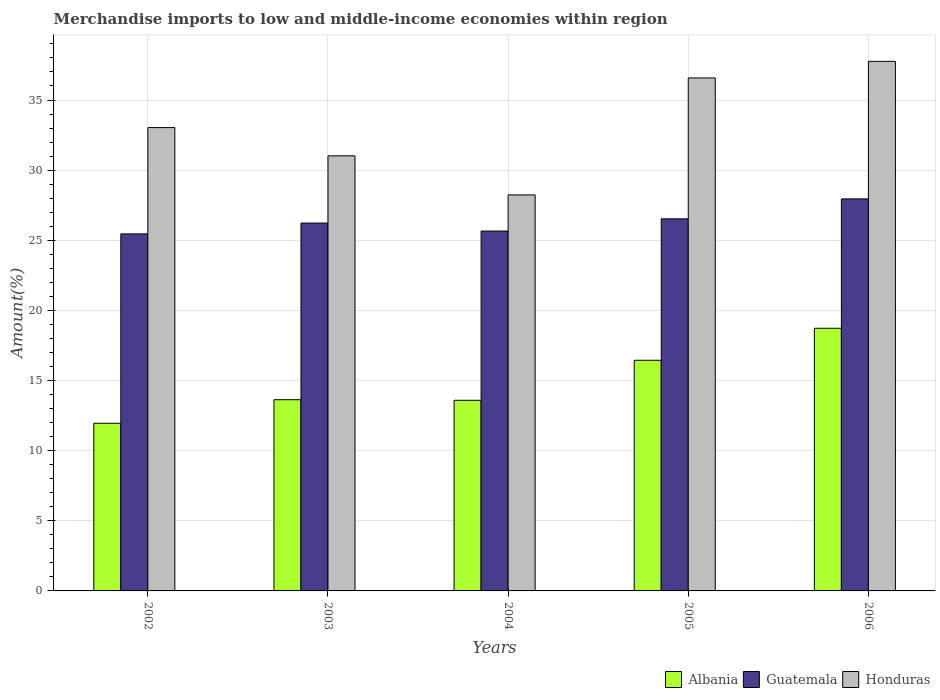Are the number of bars on each tick of the X-axis equal?
Your answer should be very brief. Yes. What is the label of the 1st group of bars from the left?
Offer a very short reply. 2002. In how many cases, is the number of bars for a given year not equal to the number of legend labels?
Make the answer very short. 0. What is the percentage of amount earned from merchandise imports in Albania in 2003?
Your answer should be compact. 13.63. Across all years, what is the maximum percentage of amount earned from merchandise imports in Albania?
Your answer should be very brief. 18.73. Across all years, what is the minimum percentage of amount earned from merchandise imports in Honduras?
Ensure brevity in your answer.  28.23. In which year was the percentage of amount earned from merchandise imports in Albania minimum?
Your answer should be compact. 2002. What is the total percentage of amount earned from merchandise imports in Guatemala in the graph?
Your answer should be very brief. 131.81. What is the difference between the percentage of amount earned from merchandise imports in Albania in 2003 and that in 2006?
Ensure brevity in your answer.  -5.09. What is the difference between the percentage of amount earned from merchandise imports in Albania in 2005 and the percentage of amount earned from merchandise imports in Guatemala in 2002?
Offer a very short reply. -9.01. What is the average percentage of amount earned from merchandise imports in Honduras per year?
Give a very brief answer. 33.32. In the year 2006, what is the difference between the percentage of amount earned from merchandise imports in Guatemala and percentage of amount earned from merchandise imports in Albania?
Provide a succinct answer. 9.22. What is the ratio of the percentage of amount earned from merchandise imports in Albania in 2002 to that in 2006?
Your answer should be compact. 0.64. What is the difference between the highest and the second highest percentage of amount earned from merchandise imports in Guatemala?
Keep it short and to the point. 1.42. What is the difference between the highest and the lowest percentage of amount earned from merchandise imports in Albania?
Ensure brevity in your answer.  6.77. In how many years, is the percentage of amount earned from merchandise imports in Albania greater than the average percentage of amount earned from merchandise imports in Albania taken over all years?
Your answer should be compact. 2. What does the 3rd bar from the left in 2005 represents?
Provide a succinct answer. Honduras. What does the 3rd bar from the right in 2006 represents?
Offer a very short reply. Albania. How many years are there in the graph?
Provide a succinct answer. 5. What is the difference between two consecutive major ticks on the Y-axis?
Make the answer very short. 5. Does the graph contain grids?
Your answer should be very brief. Yes. Where does the legend appear in the graph?
Make the answer very short. Bottom right. How many legend labels are there?
Your answer should be compact. 3. How are the legend labels stacked?
Provide a short and direct response. Horizontal. What is the title of the graph?
Your answer should be very brief. Merchandise imports to low and middle-income economies within region. What is the label or title of the X-axis?
Your response must be concise. Years. What is the label or title of the Y-axis?
Provide a short and direct response. Amount(%). What is the Amount(%) of Albania in 2002?
Ensure brevity in your answer.  11.95. What is the Amount(%) of Guatemala in 2002?
Your answer should be very brief. 25.45. What is the Amount(%) of Honduras in 2002?
Offer a terse response. 33.03. What is the Amount(%) in Albania in 2003?
Provide a short and direct response. 13.63. What is the Amount(%) in Guatemala in 2003?
Your answer should be compact. 26.23. What is the Amount(%) in Honduras in 2003?
Your answer should be very brief. 31.02. What is the Amount(%) of Albania in 2004?
Provide a succinct answer. 13.59. What is the Amount(%) in Guatemala in 2004?
Offer a terse response. 25.66. What is the Amount(%) in Honduras in 2004?
Provide a short and direct response. 28.23. What is the Amount(%) in Albania in 2005?
Make the answer very short. 16.44. What is the Amount(%) in Guatemala in 2005?
Provide a succinct answer. 26.53. What is the Amount(%) of Honduras in 2005?
Ensure brevity in your answer.  36.57. What is the Amount(%) in Albania in 2006?
Offer a terse response. 18.73. What is the Amount(%) of Guatemala in 2006?
Provide a succinct answer. 27.95. What is the Amount(%) of Honduras in 2006?
Make the answer very short. 37.76. Across all years, what is the maximum Amount(%) of Albania?
Offer a terse response. 18.73. Across all years, what is the maximum Amount(%) of Guatemala?
Give a very brief answer. 27.95. Across all years, what is the maximum Amount(%) in Honduras?
Offer a terse response. 37.76. Across all years, what is the minimum Amount(%) in Albania?
Offer a terse response. 11.95. Across all years, what is the minimum Amount(%) of Guatemala?
Provide a short and direct response. 25.45. Across all years, what is the minimum Amount(%) of Honduras?
Provide a short and direct response. 28.23. What is the total Amount(%) in Albania in the graph?
Your answer should be very brief. 74.35. What is the total Amount(%) of Guatemala in the graph?
Give a very brief answer. 131.81. What is the total Amount(%) of Honduras in the graph?
Offer a very short reply. 166.62. What is the difference between the Amount(%) in Albania in 2002 and that in 2003?
Provide a short and direct response. -1.68. What is the difference between the Amount(%) of Guatemala in 2002 and that in 2003?
Provide a short and direct response. -0.77. What is the difference between the Amount(%) of Honduras in 2002 and that in 2003?
Make the answer very short. 2.01. What is the difference between the Amount(%) in Albania in 2002 and that in 2004?
Provide a short and direct response. -1.64. What is the difference between the Amount(%) in Guatemala in 2002 and that in 2004?
Make the answer very short. -0.2. What is the difference between the Amount(%) of Honduras in 2002 and that in 2004?
Provide a short and direct response. 4.8. What is the difference between the Amount(%) of Albania in 2002 and that in 2005?
Provide a short and direct response. -4.49. What is the difference between the Amount(%) of Guatemala in 2002 and that in 2005?
Your answer should be very brief. -1.07. What is the difference between the Amount(%) in Honduras in 2002 and that in 2005?
Give a very brief answer. -3.54. What is the difference between the Amount(%) of Albania in 2002 and that in 2006?
Ensure brevity in your answer.  -6.77. What is the difference between the Amount(%) in Guatemala in 2002 and that in 2006?
Give a very brief answer. -2.49. What is the difference between the Amount(%) in Honduras in 2002 and that in 2006?
Offer a very short reply. -4.72. What is the difference between the Amount(%) of Albania in 2003 and that in 2004?
Make the answer very short. 0.04. What is the difference between the Amount(%) of Guatemala in 2003 and that in 2004?
Keep it short and to the point. 0.57. What is the difference between the Amount(%) in Honduras in 2003 and that in 2004?
Provide a short and direct response. 2.79. What is the difference between the Amount(%) in Albania in 2003 and that in 2005?
Offer a very short reply. -2.81. What is the difference between the Amount(%) in Guatemala in 2003 and that in 2005?
Provide a short and direct response. -0.3. What is the difference between the Amount(%) in Honduras in 2003 and that in 2005?
Provide a short and direct response. -5.55. What is the difference between the Amount(%) in Albania in 2003 and that in 2006?
Offer a terse response. -5.09. What is the difference between the Amount(%) in Guatemala in 2003 and that in 2006?
Your response must be concise. -1.72. What is the difference between the Amount(%) in Honduras in 2003 and that in 2006?
Your response must be concise. -6.74. What is the difference between the Amount(%) in Albania in 2004 and that in 2005?
Offer a terse response. -2.85. What is the difference between the Amount(%) of Guatemala in 2004 and that in 2005?
Provide a short and direct response. -0.87. What is the difference between the Amount(%) in Honduras in 2004 and that in 2005?
Offer a terse response. -8.34. What is the difference between the Amount(%) of Albania in 2004 and that in 2006?
Make the answer very short. -5.14. What is the difference between the Amount(%) of Guatemala in 2004 and that in 2006?
Offer a terse response. -2.29. What is the difference between the Amount(%) in Honduras in 2004 and that in 2006?
Ensure brevity in your answer.  -9.52. What is the difference between the Amount(%) in Albania in 2005 and that in 2006?
Make the answer very short. -2.28. What is the difference between the Amount(%) in Guatemala in 2005 and that in 2006?
Make the answer very short. -1.42. What is the difference between the Amount(%) in Honduras in 2005 and that in 2006?
Your answer should be very brief. -1.18. What is the difference between the Amount(%) in Albania in 2002 and the Amount(%) in Guatemala in 2003?
Your response must be concise. -14.27. What is the difference between the Amount(%) in Albania in 2002 and the Amount(%) in Honduras in 2003?
Offer a terse response. -19.07. What is the difference between the Amount(%) of Guatemala in 2002 and the Amount(%) of Honduras in 2003?
Provide a short and direct response. -5.56. What is the difference between the Amount(%) of Albania in 2002 and the Amount(%) of Guatemala in 2004?
Ensure brevity in your answer.  -13.7. What is the difference between the Amount(%) in Albania in 2002 and the Amount(%) in Honduras in 2004?
Provide a succinct answer. -16.28. What is the difference between the Amount(%) in Guatemala in 2002 and the Amount(%) in Honduras in 2004?
Give a very brief answer. -2.78. What is the difference between the Amount(%) of Albania in 2002 and the Amount(%) of Guatemala in 2005?
Give a very brief answer. -14.57. What is the difference between the Amount(%) of Albania in 2002 and the Amount(%) of Honduras in 2005?
Your answer should be compact. -24.62. What is the difference between the Amount(%) in Guatemala in 2002 and the Amount(%) in Honduras in 2005?
Keep it short and to the point. -11.12. What is the difference between the Amount(%) in Albania in 2002 and the Amount(%) in Guatemala in 2006?
Your answer should be compact. -16. What is the difference between the Amount(%) of Albania in 2002 and the Amount(%) of Honduras in 2006?
Your answer should be very brief. -25.8. What is the difference between the Amount(%) of Guatemala in 2002 and the Amount(%) of Honduras in 2006?
Offer a terse response. -12.3. What is the difference between the Amount(%) in Albania in 2003 and the Amount(%) in Guatemala in 2004?
Offer a very short reply. -12.02. What is the difference between the Amount(%) in Albania in 2003 and the Amount(%) in Honduras in 2004?
Your answer should be very brief. -14.6. What is the difference between the Amount(%) in Guatemala in 2003 and the Amount(%) in Honduras in 2004?
Ensure brevity in your answer.  -2.01. What is the difference between the Amount(%) in Albania in 2003 and the Amount(%) in Guatemala in 2005?
Your answer should be compact. -12.9. What is the difference between the Amount(%) of Albania in 2003 and the Amount(%) of Honduras in 2005?
Your response must be concise. -22.94. What is the difference between the Amount(%) of Guatemala in 2003 and the Amount(%) of Honduras in 2005?
Offer a very short reply. -10.35. What is the difference between the Amount(%) of Albania in 2003 and the Amount(%) of Guatemala in 2006?
Give a very brief answer. -14.32. What is the difference between the Amount(%) in Albania in 2003 and the Amount(%) in Honduras in 2006?
Give a very brief answer. -24.12. What is the difference between the Amount(%) of Guatemala in 2003 and the Amount(%) of Honduras in 2006?
Provide a succinct answer. -11.53. What is the difference between the Amount(%) of Albania in 2004 and the Amount(%) of Guatemala in 2005?
Your response must be concise. -12.94. What is the difference between the Amount(%) in Albania in 2004 and the Amount(%) in Honduras in 2005?
Your response must be concise. -22.98. What is the difference between the Amount(%) in Guatemala in 2004 and the Amount(%) in Honduras in 2005?
Ensure brevity in your answer.  -10.92. What is the difference between the Amount(%) of Albania in 2004 and the Amount(%) of Guatemala in 2006?
Your response must be concise. -14.36. What is the difference between the Amount(%) in Albania in 2004 and the Amount(%) in Honduras in 2006?
Your answer should be compact. -24.16. What is the difference between the Amount(%) in Guatemala in 2004 and the Amount(%) in Honduras in 2006?
Give a very brief answer. -12.1. What is the difference between the Amount(%) in Albania in 2005 and the Amount(%) in Guatemala in 2006?
Provide a succinct answer. -11.51. What is the difference between the Amount(%) of Albania in 2005 and the Amount(%) of Honduras in 2006?
Provide a succinct answer. -21.31. What is the difference between the Amount(%) in Guatemala in 2005 and the Amount(%) in Honduras in 2006?
Provide a short and direct response. -11.23. What is the average Amount(%) in Albania per year?
Your answer should be very brief. 14.87. What is the average Amount(%) in Guatemala per year?
Give a very brief answer. 26.36. What is the average Amount(%) in Honduras per year?
Keep it short and to the point. 33.32. In the year 2002, what is the difference between the Amount(%) in Albania and Amount(%) in Guatemala?
Make the answer very short. -13.5. In the year 2002, what is the difference between the Amount(%) of Albania and Amount(%) of Honduras?
Give a very brief answer. -21.08. In the year 2002, what is the difference between the Amount(%) of Guatemala and Amount(%) of Honduras?
Ensure brevity in your answer.  -7.58. In the year 2003, what is the difference between the Amount(%) of Albania and Amount(%) of Guatemala?
Make the answer very short. -12.59. In the year 2003, what is the difference between the Amount(%) in Albania and Amount(%) in Honduras?
Offer a terse response. -17.39. In the year 2003, what is the difference between the Amount(%) of Guatemala and Amount(%) of Honduras?
Provide a succinct answer. -4.79. In the year 2004, what is the difference between the Amount(%) in Albania and Amount(%) in Guatemala?
Offer a very short reply. -12.06. In the year 2004, what is the difference between the Amount(%) of Albania and Amount(%) of Honduras?
Ensure brevity in your answer.  -14.64. In the year 2004, what is the difference between the Amount(%) in Guatemala and Amount(%) in Honduras?
Provide a short and direct response. -2.58. In the year 2005, what is the difference between the Amount(%) of Albania and Amount(%) of Guatemala?
Your answer should be compact. -10.08. In the year 2005, what is the difference between the Amount(%) of Albania and Amount(%) of Honduras?
Your answer should be compact. -20.13. In the year 2005, what is the difference between the Amount(%) in Guatemala and Amount(%) in Honduras?
Your answer should be very brief. -10.05. In the year 2006, what is the difference between the Amount(%) of Albania and Amount(%) of Guatemala?
Give a very brief answer. -9.22. In the year 2006, what is the difference between the Amount(%) in Albania and Amount(%) in Honduras?
Ensure brevity in your answer.  -19.03. In the year 2006, what is the difference between the Amount(%) in Guatemala and Amount(%) in Honduras?
Your answer should be compact. -9.81. What is the ratio of the Amount(%) in Albania in 2002 to that in 2003?
Make the answer very short. 0.88. What is the ratio of the Amount(%) in Guatemala in 2002 to that in 2003?
Make the answer very short. 0.97. What is the ratio of the Amount(%) of Honduras in 2002 to that in 2003?
Offer a very short reply. 1.06. What is the ratio of the Amount(%) in Albania in 2002 to that in 2004?
Provide a short and direct response. 0.88. What is the ratio of the Amount(%) of Honduras in 2002 to that in 2004?
Provide a succinct answer. 1.17. What is the ratio of the Amount(%) in Albania in 2002 to that in 2005?
Offer a very short reply. 0.73. What is the ratio of the Amount(%) of Guatemala in 2002 to that in 2005?
Your response must be concise. 0.96. What is the ratio of the Amount(%) of Honduras in 2002 to that in 2005?
Make the answer very short. 0.9. What is the ratio of the Amount(%) in Albania in 2002 to that in 2006?
Your response must be concise. 0.64. What is the ratio of the Amount(%) in Guatemala in 2002 to that in 2006?
Provide a succinct answer. 0.91. What is the ratio of the Amount(%) in Honduras in 2002 to that in 2006?
Provide a succinct answer. 0.87. What is the ratio of the Amount(%) of Albania in 2003 to that in 2004?
Your answer should be compact. 1. What is the ratio of the Amount(%) of Guatemala in 2003 to that in 2004?
Offer a very short reply. 1.02. What is the ratio of the Amount(%) of Honduras in 2003 to that in 2004?
Provide a short and direct response. 1.1. What is the ratio of the Amount(%) in Albania in 2003 to that in 2005?
Your answer should be very brief. 0.83. What is the ratio of the Amount(%) in Guatemala in 2003 to that in 2005?
Keep it short and to the point. 0.99. What is the ratio of the Amount(%) in Honduras in 2003 to that in 2005?
Your answer should be very brief. 0.85. What is the ratio of the Amount(%) of Albania in 2003 to that in 2006?
Offer a very short reply. 0.73. What is the ratio of the Amount(%) of Guatemala in 2003 to that in 2006?
Offer a very short reply. 0.94. What is the ratio of the Amount(%) in Honduras in 2003 to that in 2006?
Ensure brevity in your answer.  0.82. What is the ratio of the Amount(%) of Albania in 2004 to that in 2005?
Offer a terse response. 0.83. What is the ratio of the Amount(%) in Guatemala in 2004 to that in 2005?
Your answer should be very brief. 0.97. What is the ratio of the Amount(%) in Honduras in 2004 to that in 2005?
Make the answer very short. 0.77. What is the ratio of the Amount(%) of Albania in 2004 to that in 2006?
Offer a very short reply. 0.73. What is the ratio of the Amount(%) in Guatemala in 2004 to that in 2006?
Offer a terse response. 0.92. What is the ratio of the Amount(%) of Honduras in 2004 to that in 2006?
Your answer should be compact. 0.75. What is the ratio of the Amount(%) of Albania in 2005 to that in 2006?
Make the answer very short. 0.88. What is the ratio of the Amount(%) in Guatemala in 2005 to that in 2006?
Your answer should be compact. 0.95. What is the ratio of the Amount(%) of Honduras in 2005 to that in 2006?
Offer a terse response. 0.97. What is the difference between the highest and the second highest Amount(%) in Albania?
Provide a short and direct response. 2.28. What is the difference between the highest and the second highest Amount(%) of Guatemala?
Offer a very short reply. 1.42. What is the difference between the highest and the second highest Amount(%) of Honduras?
Your answer should be very brief. 1.18. What is the difference between the highest and the lowest Amount(%) in Albania?
Offer a very short reply. 6.77. What is the difference between the highest and the lowest Amount(%) in Guatemala?
Ensure brevity in your answer.  2.49. What is the difference between the highest and the lowest Amount(%) in Honduras?
Your answer should be compact. 9.52. 